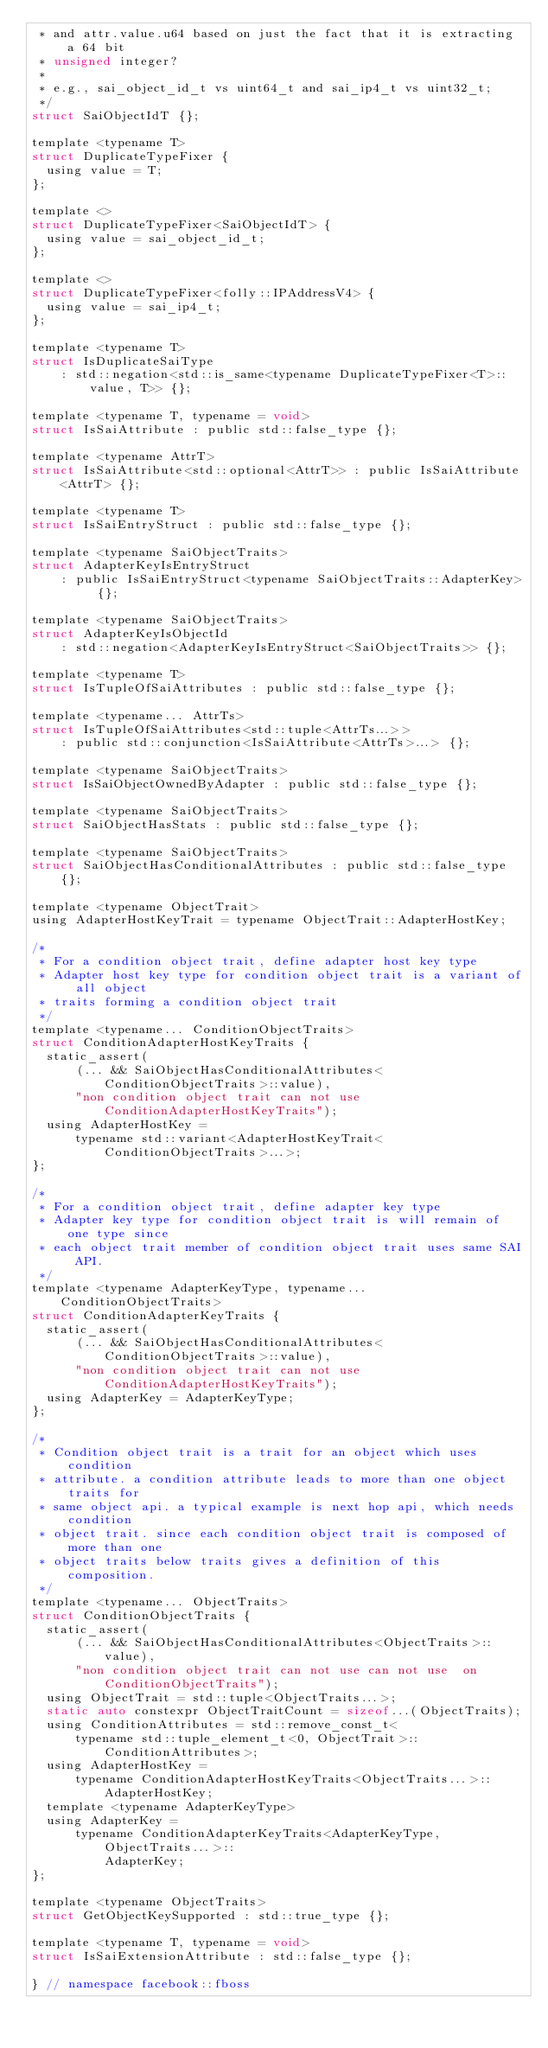<code> <loc_0><loc_0><loc_500><loc_500><_C_> * and attr.value.u64 based on just the fact that it is extracting a 64 bit
 * unsigned integer?
 *
 * e.g., sai_object_id_t vs uint64_t and sai_ip4_t vs uint32_t;
 */
struct SaiObjectIdT {};

template <typename T>
struct DuplicateTypeFixer {
  using value = T;
};

template <>
struct DuplicateTypeFixer<SaiObjectIdT> {
  using value = sai_object_id_t;
};

template <>
struct DuplicateTypeFixer<folly::IPAddressV4> {
  using value = sai_ip4_t;
};

template <typename T>
struct IsDuplicateSaiType
    : std::negation<std::is_same<typename DuplicateTypeFixer<T>::value, T>> {};

template <typename T, typename = void>
struct IsSaiAttribute : public std::false_type {};

template <typename AttrT>
struct IsSaiAttribute<std::optional<AttrT>> : public IsSaiAttribute<AttrT> {};

template <typename T>
struct IsSaiEntryStruct : public std::false_type {};

template <typename SaiObjectTraits>
struct AdapterKeyIsEntryStruct
    : public IsSaiEntryStruct<typename SaiObjectTraits::AdapterKey> {};

template <typename SaiObjectTraits>
struct AdapterKeyIsObjectId
    : std::negation<AdapterKeyIsEntryStruct<SaiObjectTraits>> {};

template <typename T>
struct IsTupleOfSaiAttributes : public std::false_type {};

template <typename... AttrTs>
struct IsTupleOfSaiAttributes<std::tuple<AttrTs...>>
    : public std::conjunction<IsSaiAttribute<AttrTs>...> {};

template <typename SaiObjectTraits>
struct IsSaiObjectOwnedByAdapter : public std::false_type {};

template <typename SaiObjectTraits>
struct SaiObjectHasStats : public std::false_type {};

template <typename SaiObjectTraits>
struct SaiObjectHasConditionalAttributes : public std::false_type {};

template <typename ObjectTrait>
using AdapterHostKeyTrait = typename ObjectTrait::AdapterHostKey;

/*
 * For a condition object trait, define adapter host key type
 * Adapter host key type for condition object trait is a variant of all object
 * traits forming a condition object trait
 */
template <typename... ConditionObjectTraits>
struct ConditionAdapterHostKeyTraits {
  static_assert(
      (... && SaiObjectHasConditionalAttributes<ConditionObjectTraits>::value),
      "non condition object trait can not use ConditionAdapterHostKeyTraits");
  using AdapterHostKey =
      typename std::variant<AdapterHostKeyTrait<ConditionObjectTraits>...>;
};

/*
 * For a condition object trait, define adapter key type
 * Adapter key type for condition object trait is will remain of one type since
 * each object trait member of condition object trait uses same SAI API.
 */
template <typename AdapterKeyType, typename... ConditionObjectTraits>
struct ConditionAdapterKeyTraits {
  static_assert(
      (... && SaiObjectHasConditionalAttributes<ConditionObjectTraits>::value),
      "non condition object trait can not use ConditionAdapterHostKeyTraits");
  using AdapterKey = AdapterKeyType;
};

/*
 * Condition object trait is a trait for an object which uses condition
 * attribute. a condition attribute leads to more than one object traits for
 * same object api. a typical example is next hop api, which needs condition
 * object trait. since each condition object trait is composed of more than one
 * object traits below traits gives a definition of this composition.
 */
template <typename... ObjectTraits>
struct ConditionObjectTraits {
  static_assert(
      (... && SaiObjectHasConditionalAttributes<ObjectTraits>::value),
      "non condition object trait can not use can not use  on ConditionObjectTraits");
  using ObjectTrait = std::tuple<ObjectTraits...>;
  static auto constexpr ObjectTraitCount = sizeof...(ObjectTraits);
  using ConditionAttributes = std::remove_const_t<
      typename std::tuple_element_t<0, ObjectTrait>::ConditionAttributes>;
  using AdapterHostKey =
      typename ConditionAdapterHostKeyTraits<ObjectTraits...>::AdapterHostKey;
  template <typename AdapterKeyType>
  using AdapterKey =
      typename ConditionAdapterKeyTraits<AdapterKeyType, ObjectTraits...>::
          AdapterKey;
};

template <typename ObjectTraits>
struct GetObjectKeySupported : std::true_type {};

template <typename T, typename = void>
struct IsSaiExtensionAttribute : std::false_type {};

} // namespace facebook::fboss
</code> 